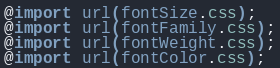<code> <loc_0><loc_0><loc_500><loc_500><_CSS_>@import url(fontSize.css);
@import url(fontFamily.css);
@import url(fontWeight.css);
@import url(fontColor.css);
</code> 